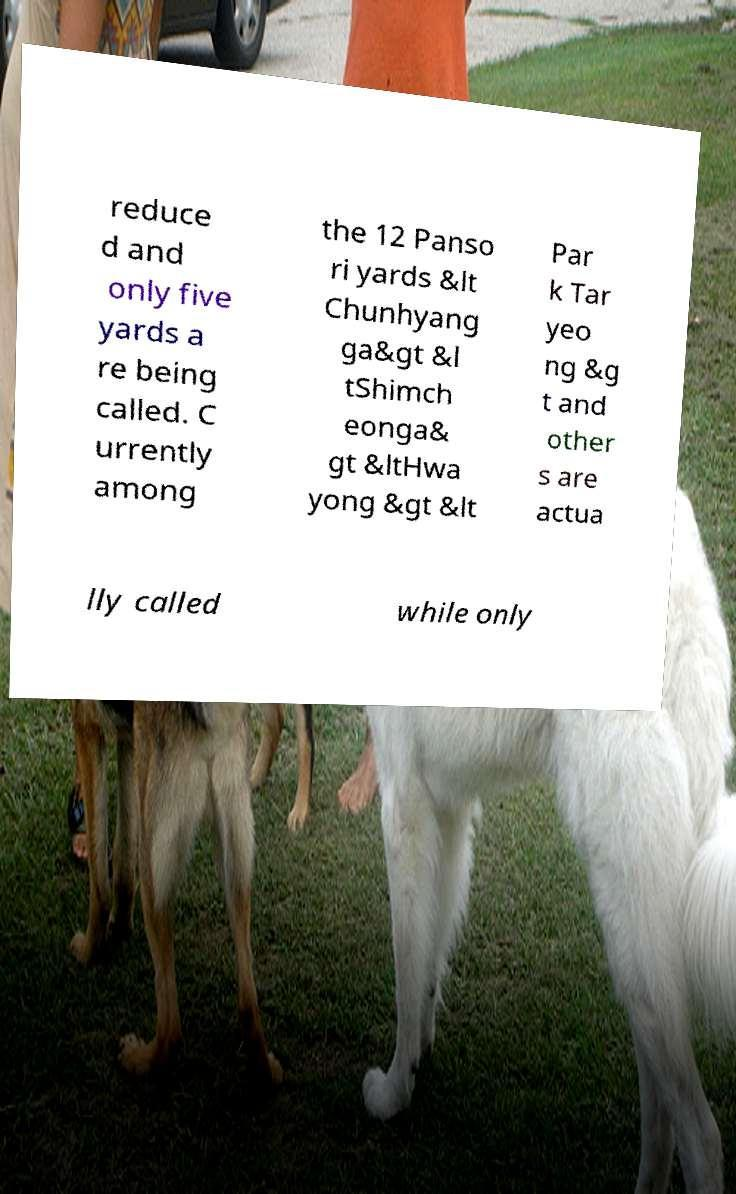What messages or text are displayed in this image? I need them in a readable, typed format. reduce d and only five yards a re being called. C urrently among the 12 Panso ri yards &lt Chunhyang ga&gt &l tShimch eonga& gt &ltHwa yong &gt &lt Par k Tar yeo ng &g t and other s are actua lly called while only 